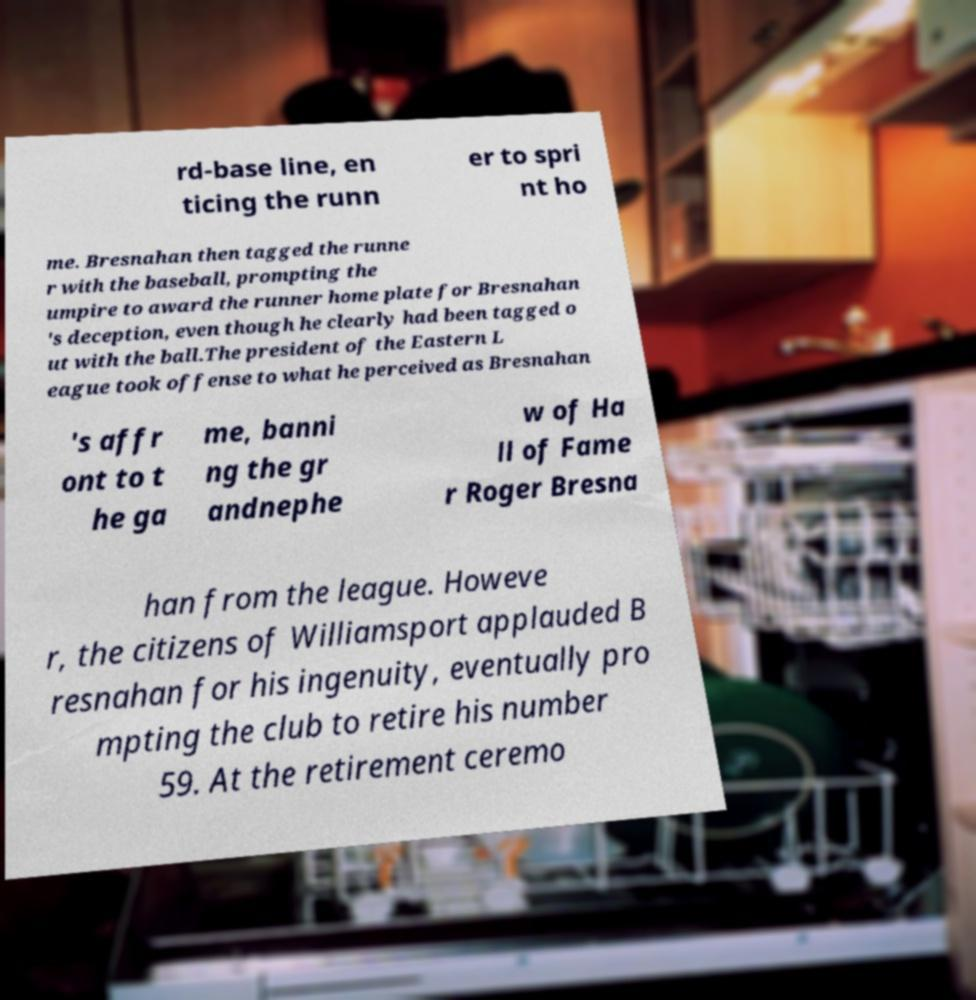Could you assist in decoding the text presented in this image and type it out clearly? rd-base line, en ticing the runn er to spri nt ho me. Bresnahan then tagged the runne r with the baseball, prompting the umpire to award the runner home plate for Bresnahan 's deception, even though he clearly had been tagged o ut with the ball.The president of the Eastern L eague took offense to what he perceived as Bresnahan 's affr ont to t he ga me, banni ng the gr andnephe w of Ha ll of Fame r Roger Bresna han from the league. Howeve r, the citizens of Williamsport applauded B resnahan for his ingenuity, eventually pro mpting the club to retire his number 59. At the retirement ceremo 